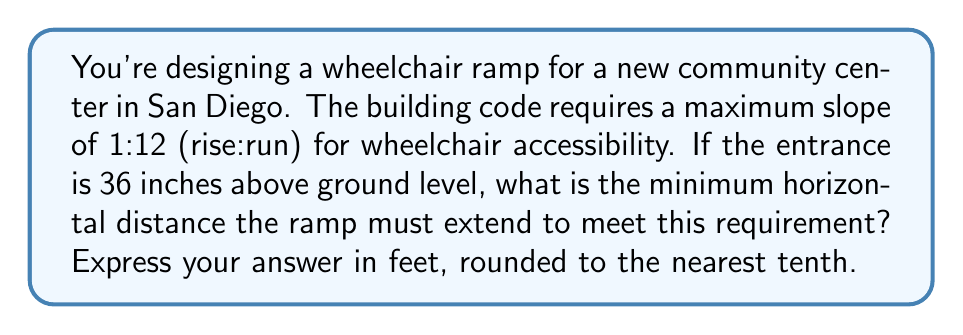Provide a solution to this math problem. Let's approach this step-by-step using trigonometry:

1) First, let's understand what a 1:12 slope means:
   For every 1 unit of rise, there must be 12 units of run.

2) We're given that the rise is 36 inches. Let's convert this to feet:
   $$ \text{Rise} = 36 \text{ inches} = 3 \text{ feet} $$

3) Now, we can set up a proportion:
   $$ \frac{\text{Rise}}{\text{Run}} = \frac{1}{12} $$

4) Substituting our known rise:
   $$ \frac{3}{\text{Run}} = \frac{1}{12} $$

5) Cross multiply:
   $$ 3 \cdot 12 = 1 \cdot \text{Run} $$
   $$ 36 = \text{Run} $$

6) Therefore, the run (horizontal distance) must be 36 feet.

7) We can verify this using the slope angle:
   $$ \tan \theta = \frac{\text{opposite}}{\text{adjacent}} = \frac{3}{36} = \frac{1}{12} $$
   $$ \theta = \arctan(\frac{1}{12}) \approx 4.76^\circ $$

   This is indeed a gentle slope suitable for wheelchairs.

[asy]
import geometry;

size(200);
draw((0,0)--(12,1), arrow=Arrow);
draw((0,0)--(12,0), dashed);
draw((12,0)--(12,1), dashed);
label("3 ft", (12,0.5), E);
label("36 ft", (6,0), S);
label("θ", (1,0.1), NW);
[/asy]
Answer: 36.0 feet 